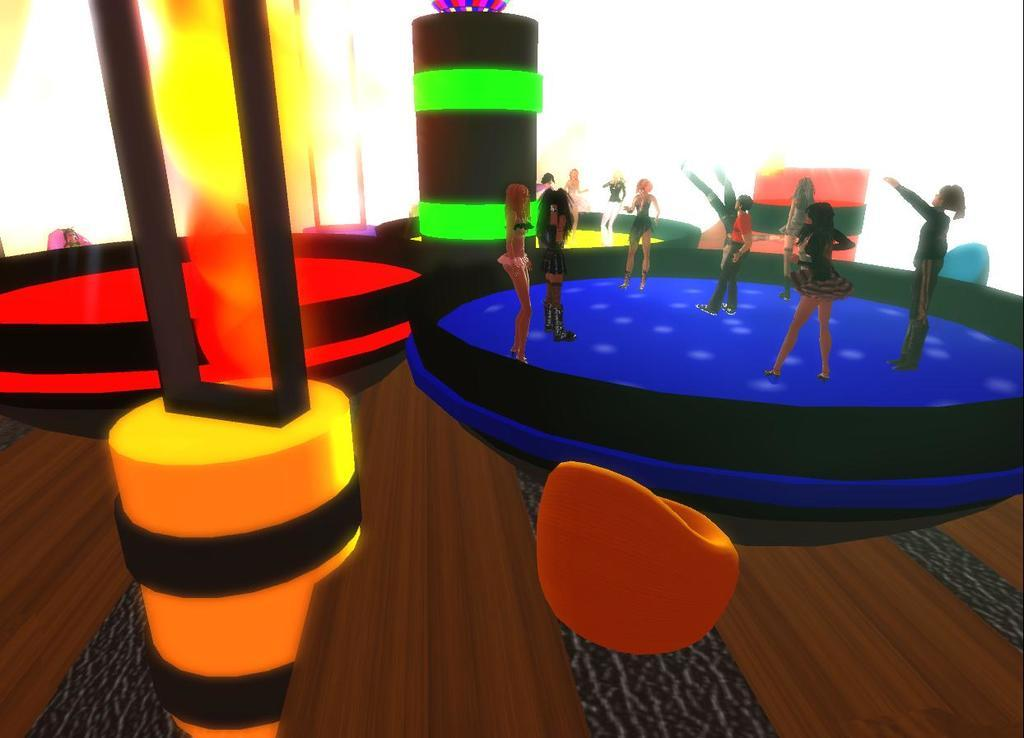What type of elements are present in the image? The image contains animated elements. Can you describe the animated people in the image? There are animated people standing on the right side of the image. What is the animated person writing on the left side of the image? There is no person writing on the left side of the image, as the facts only mention animated people standing on the right side. 